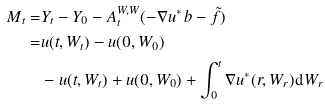<formula> <loc_0><loc_0><loc_500><loc_500>M _ { t } = & Y _ { t } - Y _ { 0 } - A ^ { W , W } _ { t } ( - \nabla u ^ { * } \, b - \tilde { f } ) \\ = & u ( t , W _ { t } ) - u ( 0 , W _ { 0 } ) \\ & - u ( t , W _ { t } ) + u ( 0 , W _ { 0 } ) + \int _ { 0 } ^ { t } \nabla u ^ { * } ( r , W _ { r } ) \mathrm d W _ { r }</formula> 